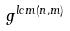Convert formula to latex. <formula><loc_0><loc_0><loc_500><loc_500>g ^ { l c m ( n , m ) }</formula> 